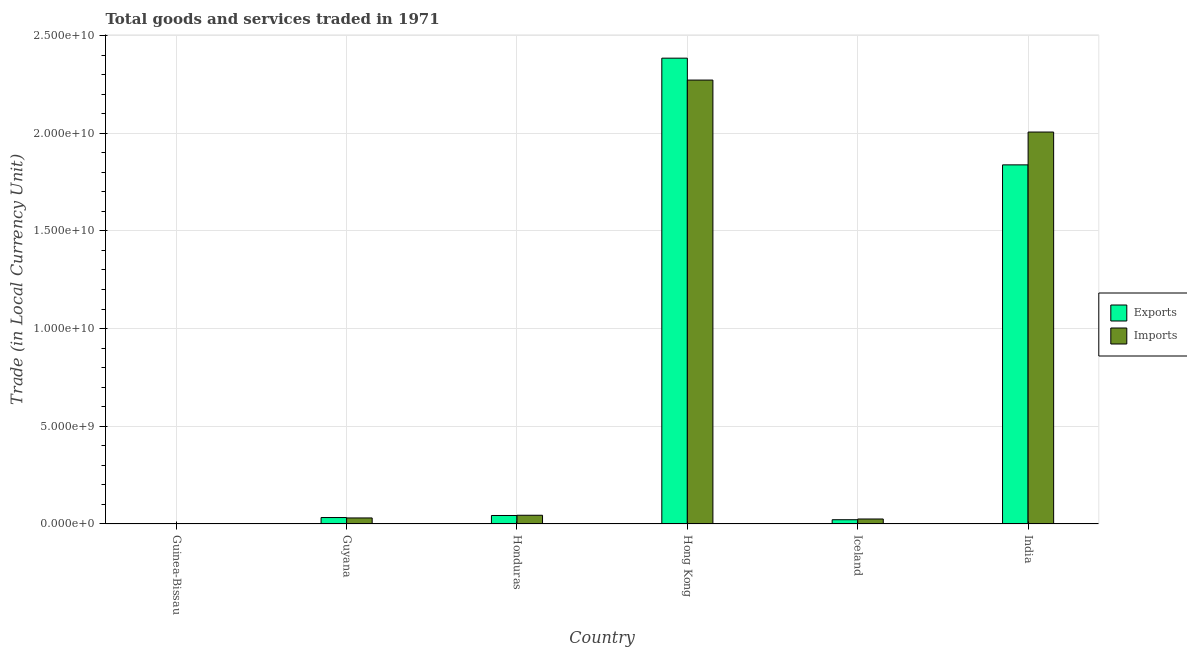How many groups of bars are there?
Keep it short and to the point. 6. Are the number of bars per tick equal to the number of legend labels?
Your answer should be very brief. Yes. How many bars are there on the 2nd tick from the left?
Make the answer very short. 2. How many bars are there on the 3rd tick from the right?
Give a very brief answer. 2. What is the label of the 1st group of bars from the left?
Make the answer very short. Guinea-Bissau. In how many cases, is the number of bars for a given country not equal to the number of legend labels?
Offer a very short reply. 0. What is the export of goods and services in India?
Your answer should be very brief. 1.84e+1. Across all countries, what is the maximum imports of goods and services?
Offer a terse response. 2.27e+1. Across all countries, what is the minimum imports of goods and services?
Your answer should be very brief. 1.45e+07. In which country was the export of goods and services maximum?
Keep it short and to the point. Hong Kong. In which country was the imports of goods and services minimum?
Your answer should be compact. Guinea-Bissau. What is the total imports of goods and services in the graph?
Offer a very short reply. 4.38e+1. What is the difference between the export of goods and services in Guyana and that in Iceland?
Keep it short and to the point. 1.12e+08. What is the difference between the imports of goods and services in Guinea-Bissau and the export of goods and services in Hong Kong?
Give a very brief answer. -2.38e+1. What is the average imports of goods and services per country?
Keep it short and to the point. 7.30e+09. What is the difference between the imports of goods and services and export of goods and services in Iceland?
Provide a succinct answer. 3.77e+07. What is the ratio of the export of goods and services in Guyana to that in India?
Provide a short and direct response. 0.02. What is the difference between the highest and the second highest export of goods and services?
Offer a terse response. 5.46e+09. What is the difference between the highest and the lowest imports of goods and services?
Give a very brief answer. 2.27e+1. In how many countries, is the export of goods and services greater than the average export of goods and services taken over all countries?
Your answer should be compact. 2. Is the sum of the imports of goods and services in Guyana and Honduras greater than the maximum export of goods and services across all countries?
Keep it short and to the point. No. What does the 2nd bar from the left in Iceland represents?
Provide a short and direct response. Imports. What does the 2nd bar from the right in Iceland represents?
Give a very brief answer. Exports. How many bars are there?
Provide a short and direct response. 12. How many countries are there in the graph?
Provide a succinct answer. 6. What is the difference between two consecutive major ticks on the Y-axis?
Your response must be concise. 5.00e+09. Are the values on the major ticks of Y-axis written in scientific E-notation?
Ensure brevity in your answer.  Yes. Does the graph contain any zero values?
Keep it short and to the point. No. Does the graph contain grids?
Keep it short and to the point. Yes. Where does the legend appear in the graph?
Ensure brevity in your answer.  Center right. How many legend labels are there?
Your answer should be compact. 2. What is the title of the graph?
Offer a terse response. Total goods and services traded in 1971. What is the label or title of the X-axis?
Keep it short and to the point. Country. What is the label or title of the Y-axis?
Provide a succinct answer. Trade (in Local Currency Unit). What is the Trade (in Local Currency Unit) of Exports in Guinea-Bissau?
Your response must be concise. 1.76e+06. What is the Trade (in Local Currency Unit) of Imports in Guinea-Bissau?
Offer a terse response. 1.45e+07. What is the Trade (in Local Currency Unit) of Exports in Guyana?
Your response must be concise. 3.30e+08. What is the Trade (in Local Currency Unit) of Imports in Guyana?
Make the answer very short. 3.08e+08. What is the Trade (in Local Currency Unit) of Exports in Honduras?
Your response must be concise. 4.34e+08. What is the Trade (in Local Currency Unit) in Imports in Honduras?
Offer a terse response. 4.46e+08. What is the Trade (in Local Currency Unit) of Exports in Hong Kong?
Offer a very short reply. 2.38e+1. What is the Trade (in Local Currency Unit) in Imports in Hong Kong?
Your answer should be compact. 2.27e+1. What is the Trade (in Local Currency Unit) in Exports in Iceland?
Provide a succinct answer. 2.18e+08. What is the Trade (in Local Currency Unit) of Imports in Iceland?
Make the answer very short. 2.55e+08. What is the Trade (in Local Currency Unit) in Exports in India?
Offer a very short reply. 1.84e+1. What is the Trade (in Local Currency Unit) in Imports in India?
Provide a short and direct response. 2.01e+1. Across all countries, what is the maximum Trade (in Local Currency Unit) in Exports?
Offer a very short reply. 2.38e+1. Across all countries, what is the maximum Trade (in Local Currency Unit) in Imports?
Keep it short and to the point. 2.27e+1. Across all countries, what is the minimum Trade (in Local Currency Unit) of Exports?
Offer a terse response. 1.76e+06. Across all countries, what is the minimum Trade (in Local Currency Unit) of Imports?
Keep it short and to the point. 1.45e+07. What is the total Trade (in Local Currency Unit) in Exports in the graph?
Your answer should be compact. 4.32e+1. What is the total Trade (in Local Currency Unit) in Imports in the graph?
Provide a short and direct response. 4.38e+1. What is the difference between the Trade (in Local Currency Unit) in Exports in Guinea-Bissau and that in Guyana?
Keep it short and to the point. -3.28e+08. What is the difference between the Trade (in Local Currency Unit) of Imports in Guinea-Bissau and that in Guyana?
Your answer should be very brief. -2.94e+08. What is the difference between the Trade (in Local Currency Unit) of Exports in Guinea-Bissau and that in Honduras?
Offer a terse response. -4.32e+08. What is the difference between the Trade (in Local Currency Unit) in Imports in Guinea-Bissau and that in Honduras?
Provide a succinct answer. -4.31e+08. What is the difference between the Trade (in Local Currency Unit) in Exports in Guinea-Bissau and that in Hong Kong?
Offer a very short reply. -2.38e+1. What is the difference between the Trade (in Local Currency Unit) in Imports in Guinea-Bissau and that in Hong Kong?
Offer a terse response. -2.27e+1. What is the difference between the Trade (in Local Currency Unit) in Exports in Guinea-Bissau and that in Iceland?
Keep it short and to the point. -2.16e+08. What is the difference between the Trade (in Local Currency Unit) in Imports in Guinea-Bissau and that in Iceland?
Keep it short and to the point. -2.41e+08. What is the difference between the Trade (in Local Currency Unit) in Exports in Guinea-Bissau and that in India?
Provide a short and direct response. -1.84e+1. What is the difference between the Trade (in Local Currency Unit) in Imports in Guinea-Bissau and that in India?
Provide a short and direct response. -2.00e+1. What is the difference between the Trade (in Local Currency Unit) of Exports in Guyana and that in Honduras?
Keep it short and to the point. -1.04e+08. What is the difference between the Trade (in Local Currency Unit) in Imports in Guyana and that in Honduras?
Give a very brief answer. -1.38e+08. What is the difference between the Trade (in Local Currency Unit) of Exports in Guyana and that in Hong Kong?
Your answer should be very brief. -2.35e+1. What is the difference between the Trade (in Local Currency Unit) of Imports in Guyana and that in Hong Kong?
Make the answer very short. -2.24e+1. What is the difference between the Trade (in Local Currency Unit) of Exports in Guyana and that in Iceland?
Offer a terse response. 1.12e+08. What is the difference between the Trade (in Local Currency Unit) in Imports in Guyana and that in Iceland?
Ensure brevity in your answer.  5.33e+07. What is the difference between the Trade (in Local Currency Unit) of Exports in Guyana and that in India?
Your response must be concise. -1.81e+1. What is the difference between the Trade (in Local Currency Unit) of Imports in Guyana and that in India?
Your response must be concise. -1.98e+1. What is the difference between the Trade (in Local Currency Unit) of Exports in Honduras and that in Hong Kong?
Make the answer very short. -2.34e+1. What is the difference between the Trade (in Local Currency Unit) of Imports in Honduras and that in Hong Kong?
Provide a succinct answer. -2.23e+1. What is the difference between the Trade (in Local Currency Unit) in Exports in Honduras and that in Iceland?
Your answer should be compact. 2.16e+08. What is the difference between the Trade (in Local Currency Unit) of Imports in Honduras and that in Iceland?
Your response must be concise. 1.91e+08. What is the difference between the Trade (in Local Currency Unit) of Exports in Honduras and that in India?
Provide a short and direct response. -1.79e+1. What is the difference between the Trade (in Local Currency Unit) of Imports in Honduras and that in India?
Keep it short and to the point. -1.96e+1. What is the difference between the Trade (in Local Currency Unit) of Exports in Hong Kong and that in Iceland?
Offer a terse response. 2.36e+1. What is the difference between the Trade (in Local Currency Unit) in Imports in Hong Kong and that in Iceland?
Make the answer very short. 2.25e+1. What is the difference between the Trade (in Local Currency Unit) in Exports in Hong Kong and that in India?
Provide a short and direct response. 5.46e+09. What is the difference between the Trade (in Local Currency Unit) in Imports in Hong Kong and that in India?
Ensure brevity in your answer.  2.66e+09. What is the difference between the Trade (in Local Currency Unit) in Exports in Iceland and that in India?
Your response must be concise. -1.82e+1. What is the difference between the Trade (in Local Currency Unit) of Imports in Iceland and that in India?
Offer a terse response. -1.98e+1. What is the difference between the Trade (in Local Currency Unit) of Exports in Guinea-Bissau and the Trade (in Local Currency Unit) of Imports in Guyana?
Your answer should be very brief. -3.07e+08. What is the difference between the Trade (in Local Currency Unit) in Exports in Guinea-Bissau and the Trade (in Local Currency Unit) in Imports in Honduras?
Ensure brevity in your answer.  -4.44e+08. What is the difference between the Trade (in Local Currency Unit) of Exports in Guinea-Bissau and the Trade (in Local Currency Unit) of Imports in Hong Kong?
Offer a very short reply. -2.27e+1. What is the difference between the Trade (in Local Currency Unit) in Exports in Guinea-Bissau and the Trade (in Local Currency Unit) in Imports in Iceland?
Ensure brevity in your answer.  -2.53e+08. What is the difference between the Trade (in Local Currency Unit) of Exports in Guinea-Bissau and the Trade (in Local Currency Unit) of Imports in India?
Your answer should be very brief. -2.01e+1. What is the difference between the Trade (in Local Currency Unit) in Exports in Guyana and the Trade (in Local Currency Unit) in Imports in Honduras?
Your answer should be compact. -1.16e+08. What is the difference between the Trade (in Local Currency Unit) of Exports in Guyana and the Trade (in Local Currency Unit) of Imports in Hong Kong?
Ensure brevity in your answer.  -2.24e+1. What is the difference between the Trade (in Local Currency Unit) in Exports in Guyana and the Trade (in Local Currency Unit) in Imports in Iceland?
Give a very brief answer. 7.43e+07. What is the difference between the Trade (in Local Currency Unit) of Exports in Guyana and the Trade (in Local Currency Unit) of Imports in India?
Your response must be concise. -1.97e+1. What is the difference between the Trade (in Local Currency Unit) in Exports in Honduras and the Trade (in Local Currency Unit) in Imports in Hong Kong?
Provide a short and direct response. -2.23e+1. What is the difference between the Trade (in Local Currency Unit) of Exports in Honduras and the Trade (in Local Currency Unit) of Imports in Iceland?
Keep it short and to the point. 1.79e+08. What is the difference between the Trade (in Local Currency Unit) of Exports in Honduras and the Trade (in Local Currency Unit) of Imports in India?
Make the answer very short. -1.96e+1. What is the difference between the Trade (in Local Currency Unit) in Exports in Hong Kong and the Trade (in Local Currency Unit) in Imports in Iceland?
Make the answer very short. 2.36e+1. What is the difference between the Trade (in Local Currency Unit) of Exports in Hong Kong and the Trade (in Local Currency Unit) of Imports in India?
Your response must be concise. 3.78e+09. What is the difference between the Trade (in Local Currency Unit) in Exports in Iceland and the Trade (in Local Currency Unit) in Imports in India?
Give a very brief answer. -1.98e+1. What is the average Trade (in Local Currency Unit) in Exports per country?
Provide a succinct answer. 7.20e+09. What is the average Trade (in Local Currency Unit) in Imports per country?
Offer a terse response. 7.30e+09. What is the difference between the Trade (in Local Currency Unit) in Exports and Trade (in Local Currency Unit) in Imports in Guinea-Bissau?
Give a very brief answer. -1.28e+07. What is the difference between the Trade (in Local Currency Unit) in Exports and Trade (in Local Currency Unit) in Imports in Guyana?
Provide a short and direct response. 2.10e+07. What is the difference between the Trade (in Local Currency Unit) of Exports and Trade (in Local Currency Unit) of Imports in Honduras?
Your response must be concise. -1.20e+07. What is the difference between the Trade (in Local Currency Unit) of Exports and Trade (in Local Currency Unit) of Imports in Hong Kong?
Keep it short and to the point. 1.12e+09. What is the difference between the Trade (in Local Currency Unit) in Exports and Trade (in Local Currency Unit) in Imports in Iceland?
Give a very brief answer. -3.77e+07. What is the difference between the Trade (in Local Currency Unit) of Exports and Trade (in Local Currency Unit) of Imports in India?
Offer a terse response. -1.68e+09. What is the ratio of the Trade (in Local Currency Unit) of Exports in Guinea-Bissau to that in Guyana?
Your answer should be very brief. 0.01. What is the ratio of the Trade (in Local Currency Unit) in Imports in Guinea-Bissau to that in Guyana?
Your answer should be compact. 0.05. What is the ratio of the Trade (in Local Currency Unit) in Exports in Guinea-Bissau to that in Honduras?
Provide a succinct answer. 0. What is the ratio of the Trade (in Local Currency Unit) of Imports in Guinea-Bissau to that in Honduras?
Provide a succinct answer. 0.03. What is the ratio of the Trade (in Local Currency Unit) of Imports in Guinea-Bissau to that in Hong Kong?
Ensure brevity in your answer.  0. What is the ratio of the Trade (in Local Currency Unit) of Exports in Guinea-Bissau to that in Iceland?
Make the answer very short. 0.01. What is the ratio of the Trade (in Local Currency Unit) of Imports in Guinea-Bissau to that in Iceland?
Offer a terse response. 0.06. What is the ratio of the Trade (in Local Currency Unit) of Exports in Guinea-Bissau to that in India?
Offer a very short reply. 0. What is the ratio of the Trade (in Local Currency Unit) in Imports in Guinea-Bissau to that in India?
Your answer should be very brief. 0. What is the ratio of the Trade (in Local Currency Unit) in Exports in Guyana to that in Honduras?
Provide a short and direct response. 0.76. What is the ratio of the Trade (in Local Currency Unit) in Imports in Guyana to that in Honduras?
Your answer should be very brief. 0.69. What is the ratio of the Trade (in Local Currency Unit) in Exports in Guyana to that in Hong Kong?
Your response must be concise. 0.01. What is the ratio of the Trade (in Local Currency Unit) of Imports in Guyana to that in Hong Kong?
Your answer should be very brief. 0.01. What is the ratio of the Trade (in Local Currency Unit) of Exports in Guyana to that in Iceland?
Your answer should be compact. 1.51. What is the ratio of the Trade (in Local Currency Unit) in Imports in Guyana to that in Iceland?
Provide a short and direct response. 1.21. What is the ratio of the Trade (in Local Currency Unit) of Exports in Guyana to that in India?
Provide a succinct answer. 0.02. What is the ratio of the Trade (in Local Currency Unit) of Imports in Guyana to that in India?
Provide a short and direct response. 0.02. What is the ratio of the Trade (in Local Currency Unit) in Exports in Honduras to that in Hong Kong?
Provide a short and direct response. 0.02. What is the ratio of the Trade (in Local Currency Unit) of Imports in Honduras to that in Hong Kong?
Give a very brief answer. 0.02. What is the ratio of the Trade (in Local Currency Unit) in Exports in Honduras to that in Iceland?
Keep it short and to the point. 2. What is the ratio of the Trade (in Local Currency Unit) in Imports in Honduras to that in Iceland?
Make the answer very short. 1.75. What is the ratio of the Trade (in Local Currency Unit) in Exports in Honduras to that in India?
Your response must be concise. 0.02. What is the ratio of the Trade (in Local Currency Unit) in Imports in Honduras to that in India?
Provide a short and direct response. 0.02. What is the ratio of the Trade (in Local Currency Unit) in Exports in Hong Kong to that in Iceland?
Your answer should be very brief. 109.59. What is the ratio of the Trade (in Local Currency Unit) of Imports in Hong Kong to that in Iceland?
Ensure brevity in your answer.  89.02. What is the ratio of the Trade (in Local Currency Unit) in Exports in Hong Kong to that in India?
Offer a very short reply. 1.3. What is the ratio of the Trade (in Local Currency Unit) in Imports in Hong Kong to that in India?
Offer a very short reply. 1.13. What is the ratio of the Trade (in Local Currency Unit) in Exports in Iceland to that in India?
Your answer should be compact. 0.01. What is the ratio of the Trade (in Local Currency Unit) in Imports in Iceland to that in India?
Offer a very short reply. 0.01. What is the difference between the highest and the second highest Trade (in Local Currency Unit) in Exports?
Your answer should be compact. 5.46e+09. What is the difference between the highest and the second highest Trade (in Local Currency Unit) of Imports?
Your answer should be compact. 2.66e+09. What is the difference between the highest and the lowest Trade (in Local Currency Unit) of Exports?
Provide a succinct answer. 2.38e+1. What is the difference between the highest and the lowest Trade (in Local Currency Unit) of Imports?
Give a very brief answer. 2.27e+1. 